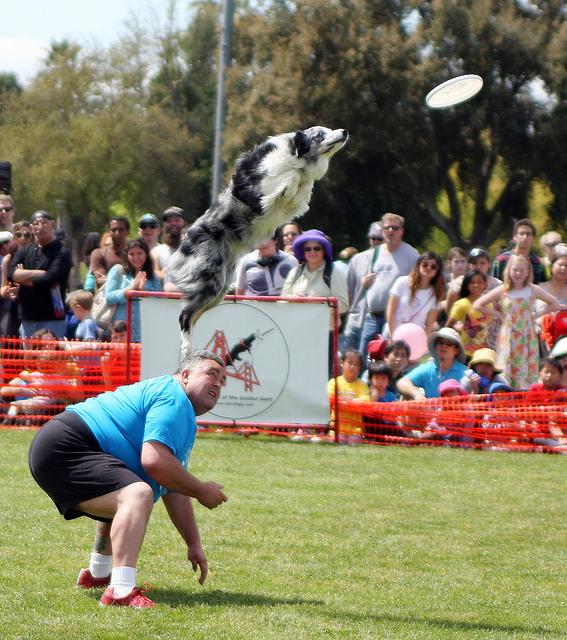Why is the dog jumping in the air?
Be succinct. To catch frisbee. Is the man wearing a hat?
Answer briefly. No. What hobby is this?
Quick response, please. Frisbee. Is the man wearing sunglasses?
Give a very brief answer. No. What white object is flying through the air?
Be succinct. Frisbee. 